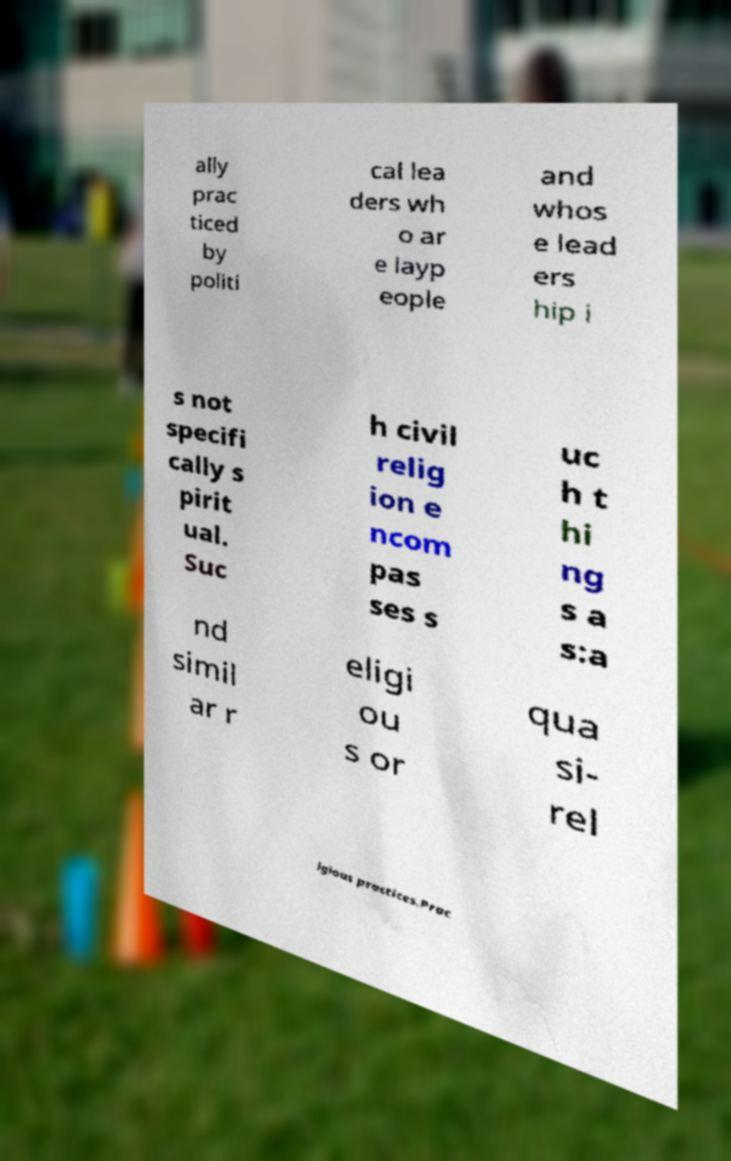Please read and relay the text visible in this image. What does it say? ally prac ticed by politi cal lea ders wh o ar e layp eople and whos e lead ers hip i s not specifi cally s pirit ual. Suc h civil relig ion e ncom pas ses s uc h t hi ng s a s:a nd simil ar r eligi ou s or qua si- rel igious practices.Prac 